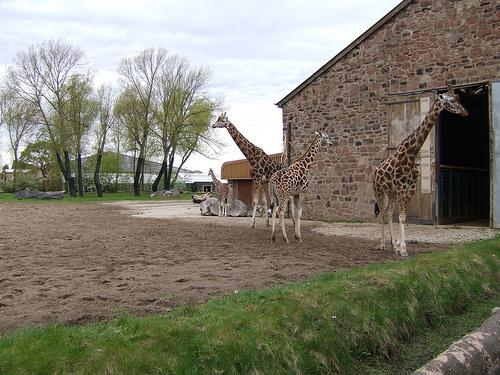Narrate the overall atmosphere of the image. The picture captures a calm and peaceful atmosphere, with giraffes leisurely roaming in their enclosure amid lush greenery and rustic buildings. Write a brief observation of the environment captured in the image. The image displays a serene environment with giraffes walking around in an enclosure, surrounded by trees, dirt, grass, and barns. Describe the setting of the image. The setting is an enclosure with giraffes, trees, dirt, grass, and brick buildings, showcasing a harmonious blend of nature and man-made structures. Sum up the image in a sentence. The image portrays a group of giraffes in an enclosure, surrounded by nature and various rustic buildings. Explain how the giraffes are situated in the enclosure. The giraffes in the enclosure are standing at different positions, with some gathered together and others roaming around near the buildings and trees. 